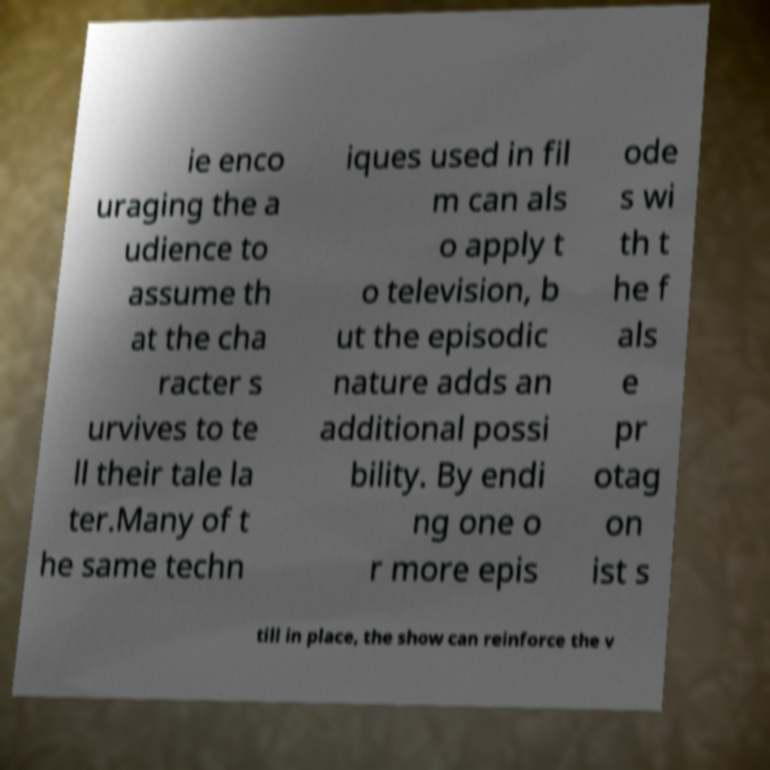For documentation purposes, I need the text within this image transcribed. Could you provide that? ie enco uraging the a udience to assume th at the cha racter s urvives to te ll their tale la ter.Many of t he same techn iques used in fil m can als o apply t o television, b ut the episodic nature adds an additional possi bility. By endi ng one o r more epis ode s wi th t he f als e pr otag on ist s till in place, the show can reinforce the v 